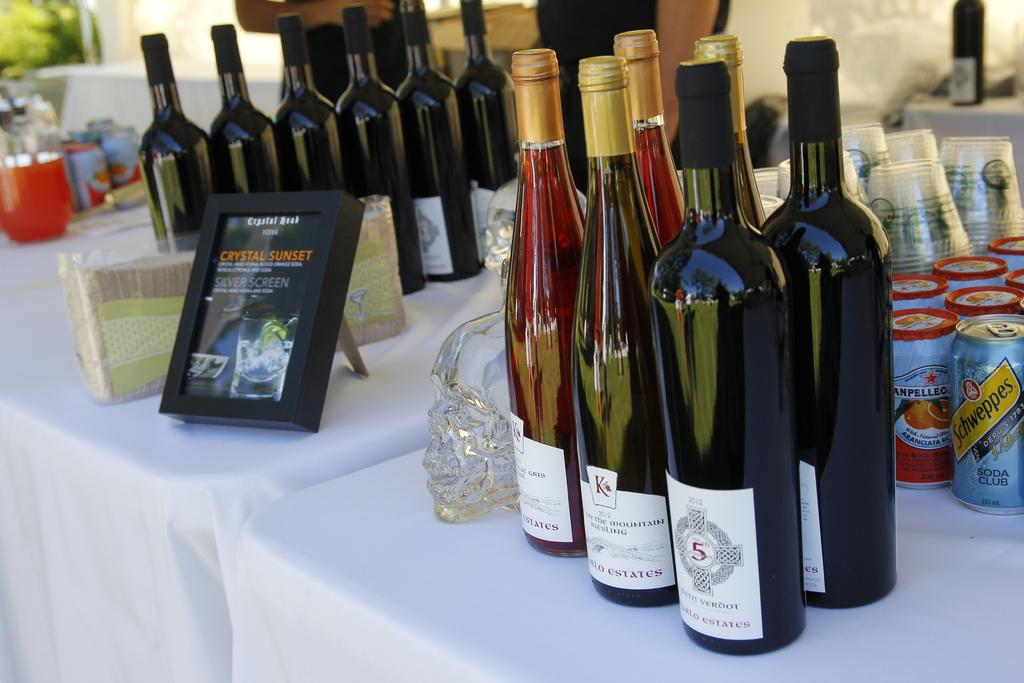<image>
Give a short and clear explanation of the subsequent image. tables with white cloth and framed sign with crystal sunset on it and several bottles of wine on it and can schweppe's club soda behind wine 